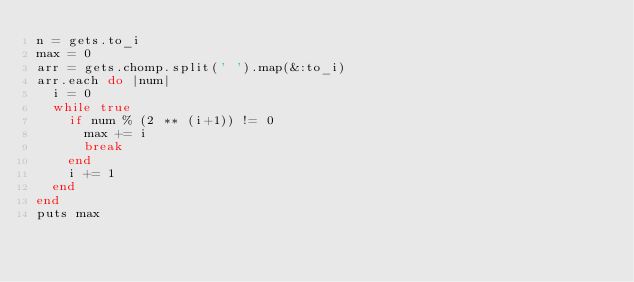Convert code to text. <code><loc_0><loc_0><loc_500><loc_500><_Ruby_>n = gets.to_i
max = 0
arr = gets.chomp.split(' ').map(&:to_i)
arr.each do |num|
  i = 0
  while true
    if num % (2 ** (i+1)) != 0
      max += i
      break
    end
    i += 1
  end
end
puts max</code> 